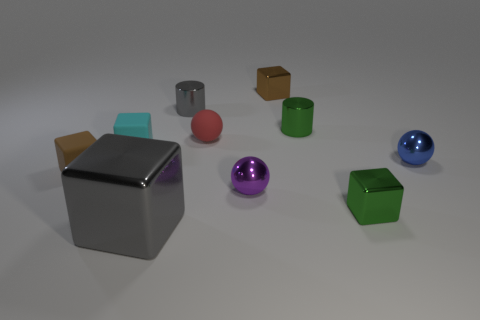There is a metal thing that is both to the left of the blue metallic thing and to the right of the green shiny cylinder; how big is it?
Offer a terse response. Small. There is a object that is the same color as the big cube; what is its shape?
Make the answer very short. Cylinder. The big metallic cube has what color?
Offer a very short reply. Gray. There is a gray shiny thing that is behind the purple sphere; what is its size?
Provide a succinct answer. Small. What number of small shiny things are in front of the brown block that is behind the small green thing that is behind the small blue object?
Your response must be concise. 5. The matte object on the right side of the metallic block that is on the left side of the small red object is what color?
Ensure brevity in your answer.  Red. Is there a gray cylinder that has the same size as the brown shiny object?
Provide a succinct answer. Yes. What material is the brown thing in front of the tiny ball that is to the right of the tiny brown cube that is to the right of the red sphere made of?
Provide a short and direct response. Rubber. How many green objects are behind the green object that is in front of the small green shiny cylinder?
Make the answer very short. 1. Do the gray shiny object behind the blue thing and the small cyan matte object have the same size?
Make the answer very short. Yes. 